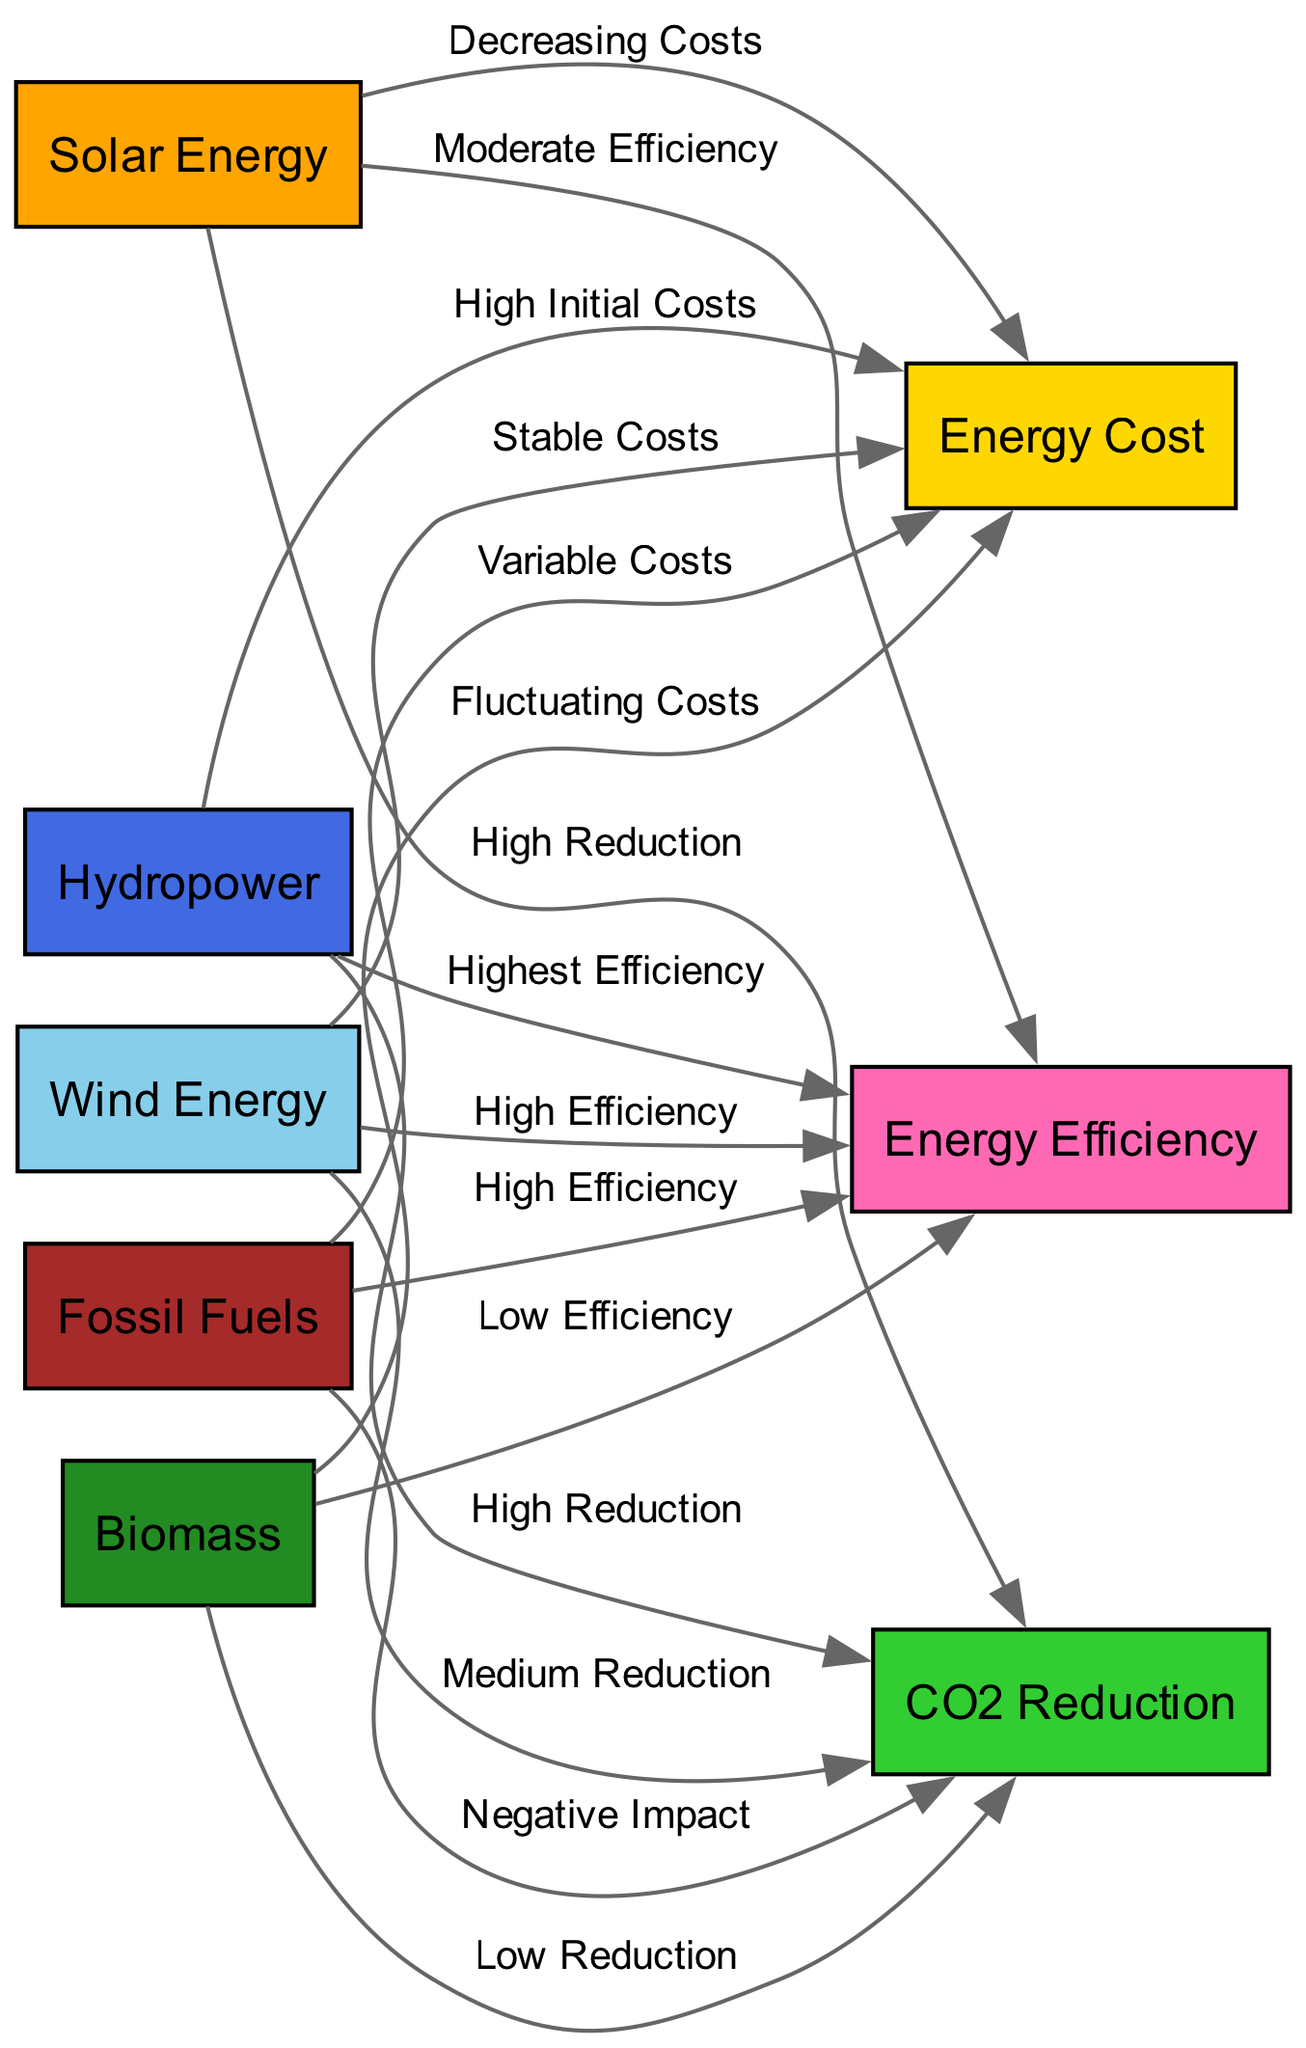What is the impact of Solar Energy on CO2 Reduction? The diagram indicates a "High Reduction" effect from Solar Energy to CO2 Reduction. This means Solar Energy significantly contributes to reducing CO2 emissions.
Answer: High Reduction How many nodes are there in the diagram? Counting the nodes listed in the data, we find there are 8 distinct nodes: Solar Energy, Wind Energy, Hydropower, Biomass, CO2 Reduction, Energy Cost, Energy Efficiency, and Fossil Fuels.
Answer: 8 What type of cost is associated with Biomass? The edge from Biomass to Energy Cost states it has "Fluctuating Costs," indicating that the price associated with Biomass can vary significantly.
Answer: Fluctuating Costs Which renewable energy source has the highest efficiency? The diagram describes Hydropower as having the "Highest Efficiency" among the renewable energy sources, indicating it performs better in efficiency metrics compared to others.
Answer: Highest Efficiency What is the relationship between Fossil Fuels and CO2 Reduction? The diagram specifies a "Negative Impact" of Fossil Fuels on CO2 Reduction, indicating that the use of Fossil Fuels contributes to an increase in CO2 emissions rather than a reduction.
Answer: Negative Impact Which renewable energy source contributes to CO2 Reduction the least? The link from Biomass to CO2 Reduction specifies "Low Reduction," suggesting that among the renewable options, Biomass contributes the least in terms of reducing CO2 emissions.
Answer: Low Reduction What is the efficiency level of Wind Energy? The diagram assigns a "High Efficiency" label to Wind Energy, indicating that this energy source is effective in converting energy input into useful energy output.
Answer: High Efficiency What type of costs are attributed to Hydropower? According to the edges, Hydropower is associated with "High Initial Costs," which suggests that while the operational costs may be lower, the initial setup is significantly costly.
Answer: High Initial Costs How does Wind Energy affect Energy Cost? The edge placed between Wind Energy and Energy Cost states "Stable Costs," implying that Wind Energy maintains a consistent cost pattern without significant fluctuations.
Answer: Stable Costs 